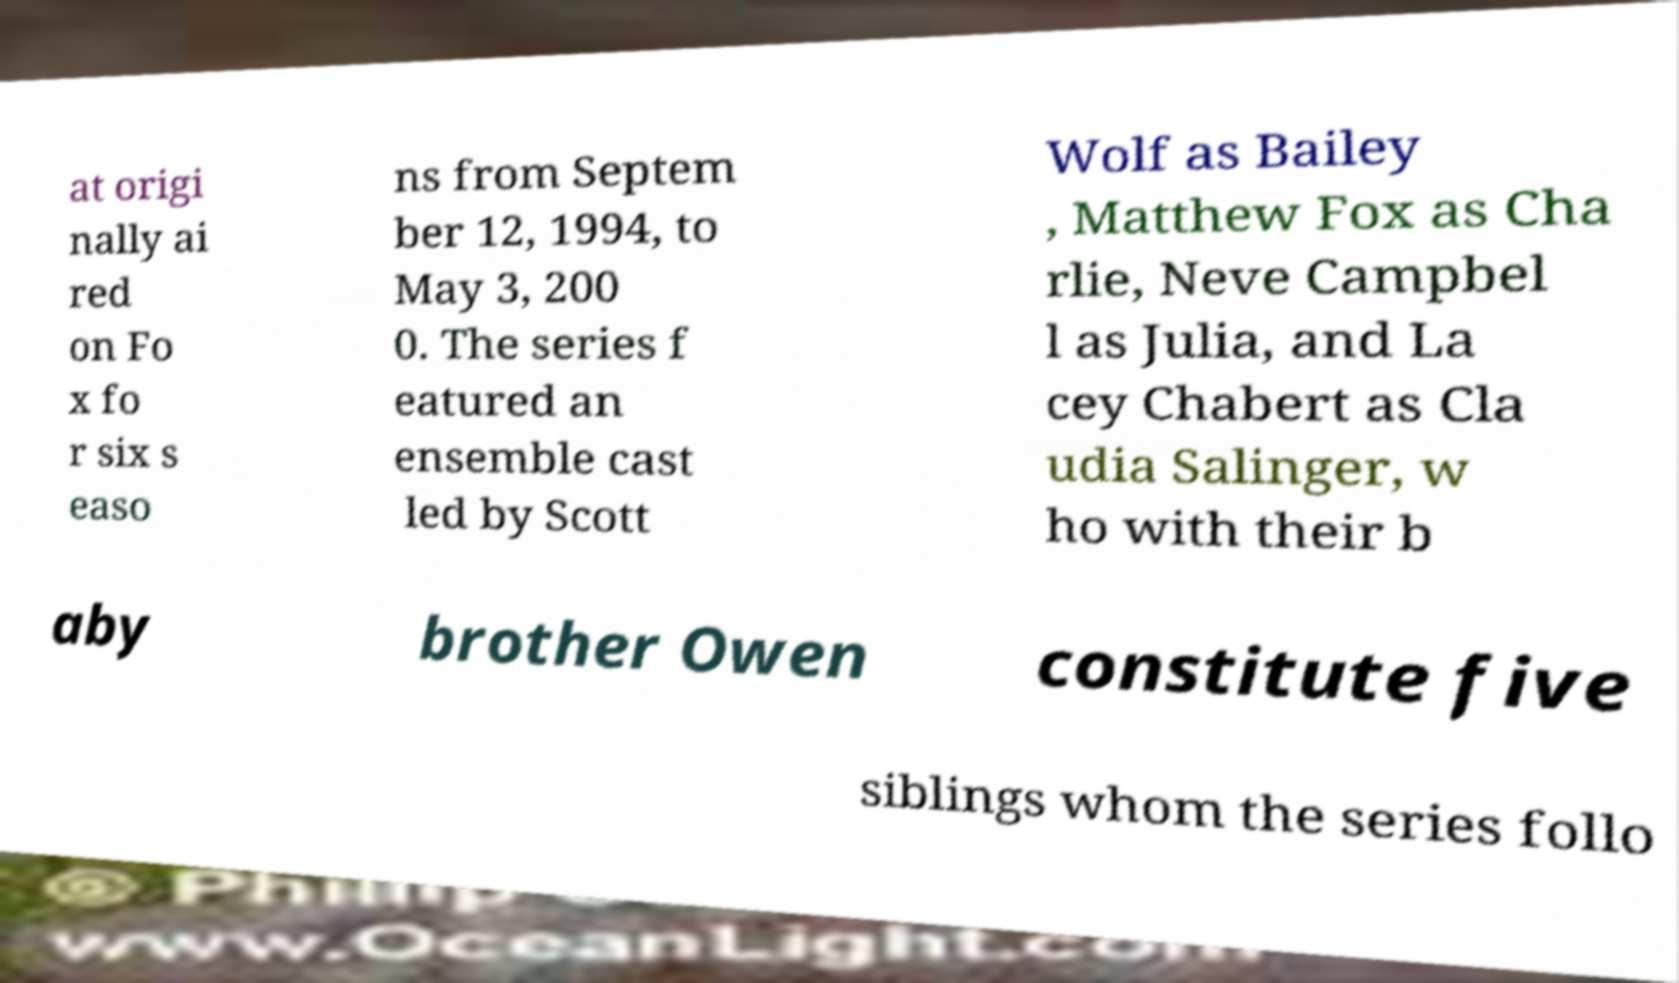There's text embedded in this image that I need extracted. Can you transcribe it verbatim? at origi nally ai red on Fo x fo r six s easo ns from Septem ber 12, 1994, to May 3, 200 0. The series f eatured an ensemble cast led by Scott Wolf as Bailey , Matthew Fox as Cha rlie, Neve Campbel l as Julia, and La cey Chabert as Cla udia Salinger, w ho with their b aby brother Owen constitute five siblings whom the series follo 